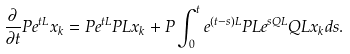<formula> <loc_0><loc_0><loc_500><loc_500>\frac { \partial } { \partial { t } } P e ^ { t L } x _ { k } = P e ^ { t L } P L x _ { k } + P \int _ { 0 } ^ { t } e ^ { ( t - s ) L } P L e ^ { s Q L } Q L x _ { k } d s .</formula> 